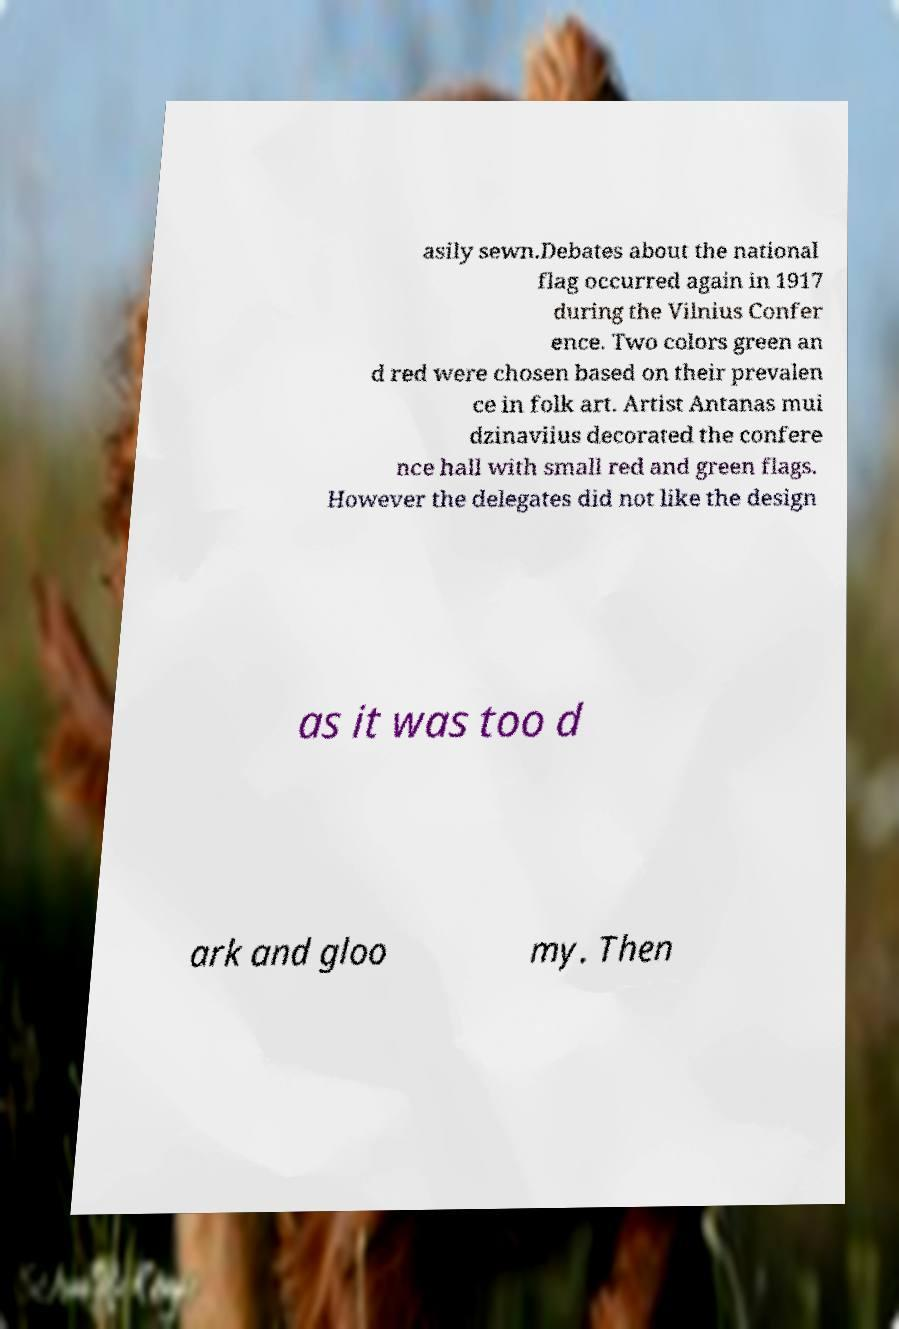I need the written content from this picture converted into text. Can you do that? asily sewn.Debates about the national flag occurred again in 1917 during the Vilnius Confer ence. Two colors green an d red were chosen based on their prevalen ce in folk art. Artist Antanas mui dzinaviius decorated the confere nce hall with small red and green flags. However the delegates did not like the design as it was too d ark and gloo my. Then 